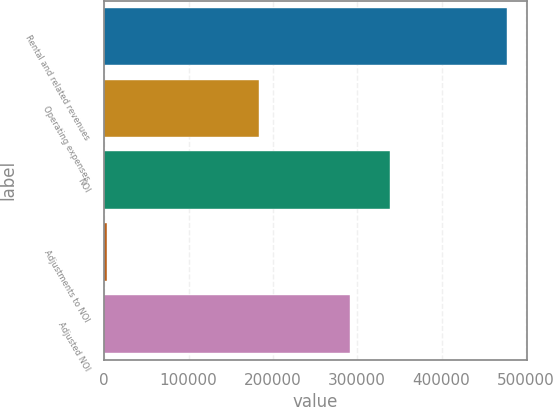<chart> <loc_0><loc_0><loc_500><loc_500><bar_chart><fcel>Rental and related revenues<fcel>Operating expenses<fcel>NOI<fcel>Adjustments to NOI<fcel>Adjusted NOI<nl><fcel>477459<fcel>183197<fcel>338761<fcel>2952<fcel>291310<nl></chart> 